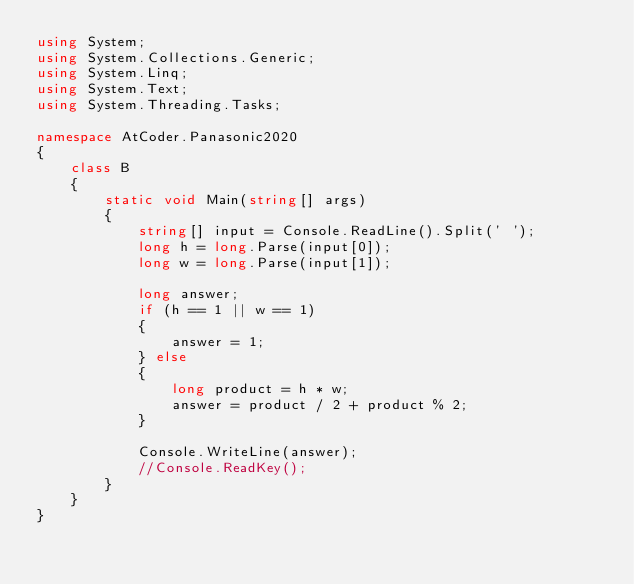<code> <loc_0><loc_0><loc_500><loc_500><_C#_>using System;
using System.Collections.Generic;
using System.Linq;
using System.Text;
using System.Threading.Tasks;

namespace AtCoder.Panasonic2020
{
    class B
    {
        static void Main(string[] args)
        {
            string[] input = Console.ReadLine().Split(' ');
            long h = long.Parse(input[0]);
            long w = long.Parse(input[1]);

            long answer;
            if (h == 1 || w == 1)
            {
                answer = 1;
            } else
            {
                long product = h * w;
                answer = product / 2 + product % 2;
            }

            Console.WriteLine(answer);
            //Console.ReadKey();
        }
    }
}
</code> 